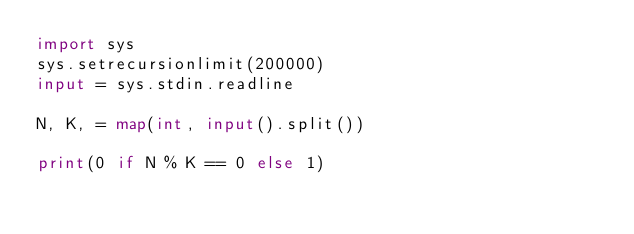Convert code to text. <code><loc_0><loc_0><loc_500><loc_500><_Python_>import sys
sys.setrecursionlimit(200000)
input = sys.stdin.readline

N, K, = map(int, input().split())

print(0 if N % K == 0 else 1)</code> 